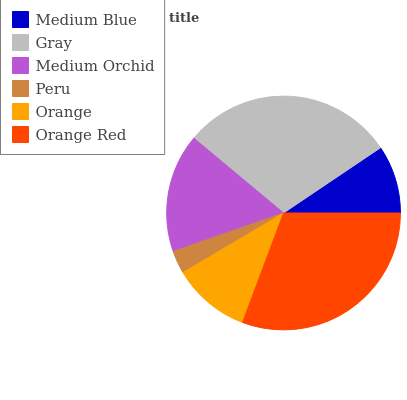Is Peru the minimum?
Answer yes or no. Yes. Is Orange Red the maximum?
Answer yes or no. Yes. Is Gray the minimum?
Answer yes or no. No. Is Gray the maximum?
Answer yes or no. No. Is Gray greater than Medium Blue?
Answer yes or no. Yes. Is Medium Blue less than Gray?
Answer yes or no. Yes. Is Medium Blue greater than Gray?
Answer yes or no. No. Is Gray less than Medium Blue?
Answer yes or no. No. Is Medium Orchid the high median?
Answer yes or no. Yes. Is Orange the low median?
Answer yes or no. Yes. Is Gray the high median?
Answer yes or no. No. Is Peru the low median?
Answer yes or no. No. 